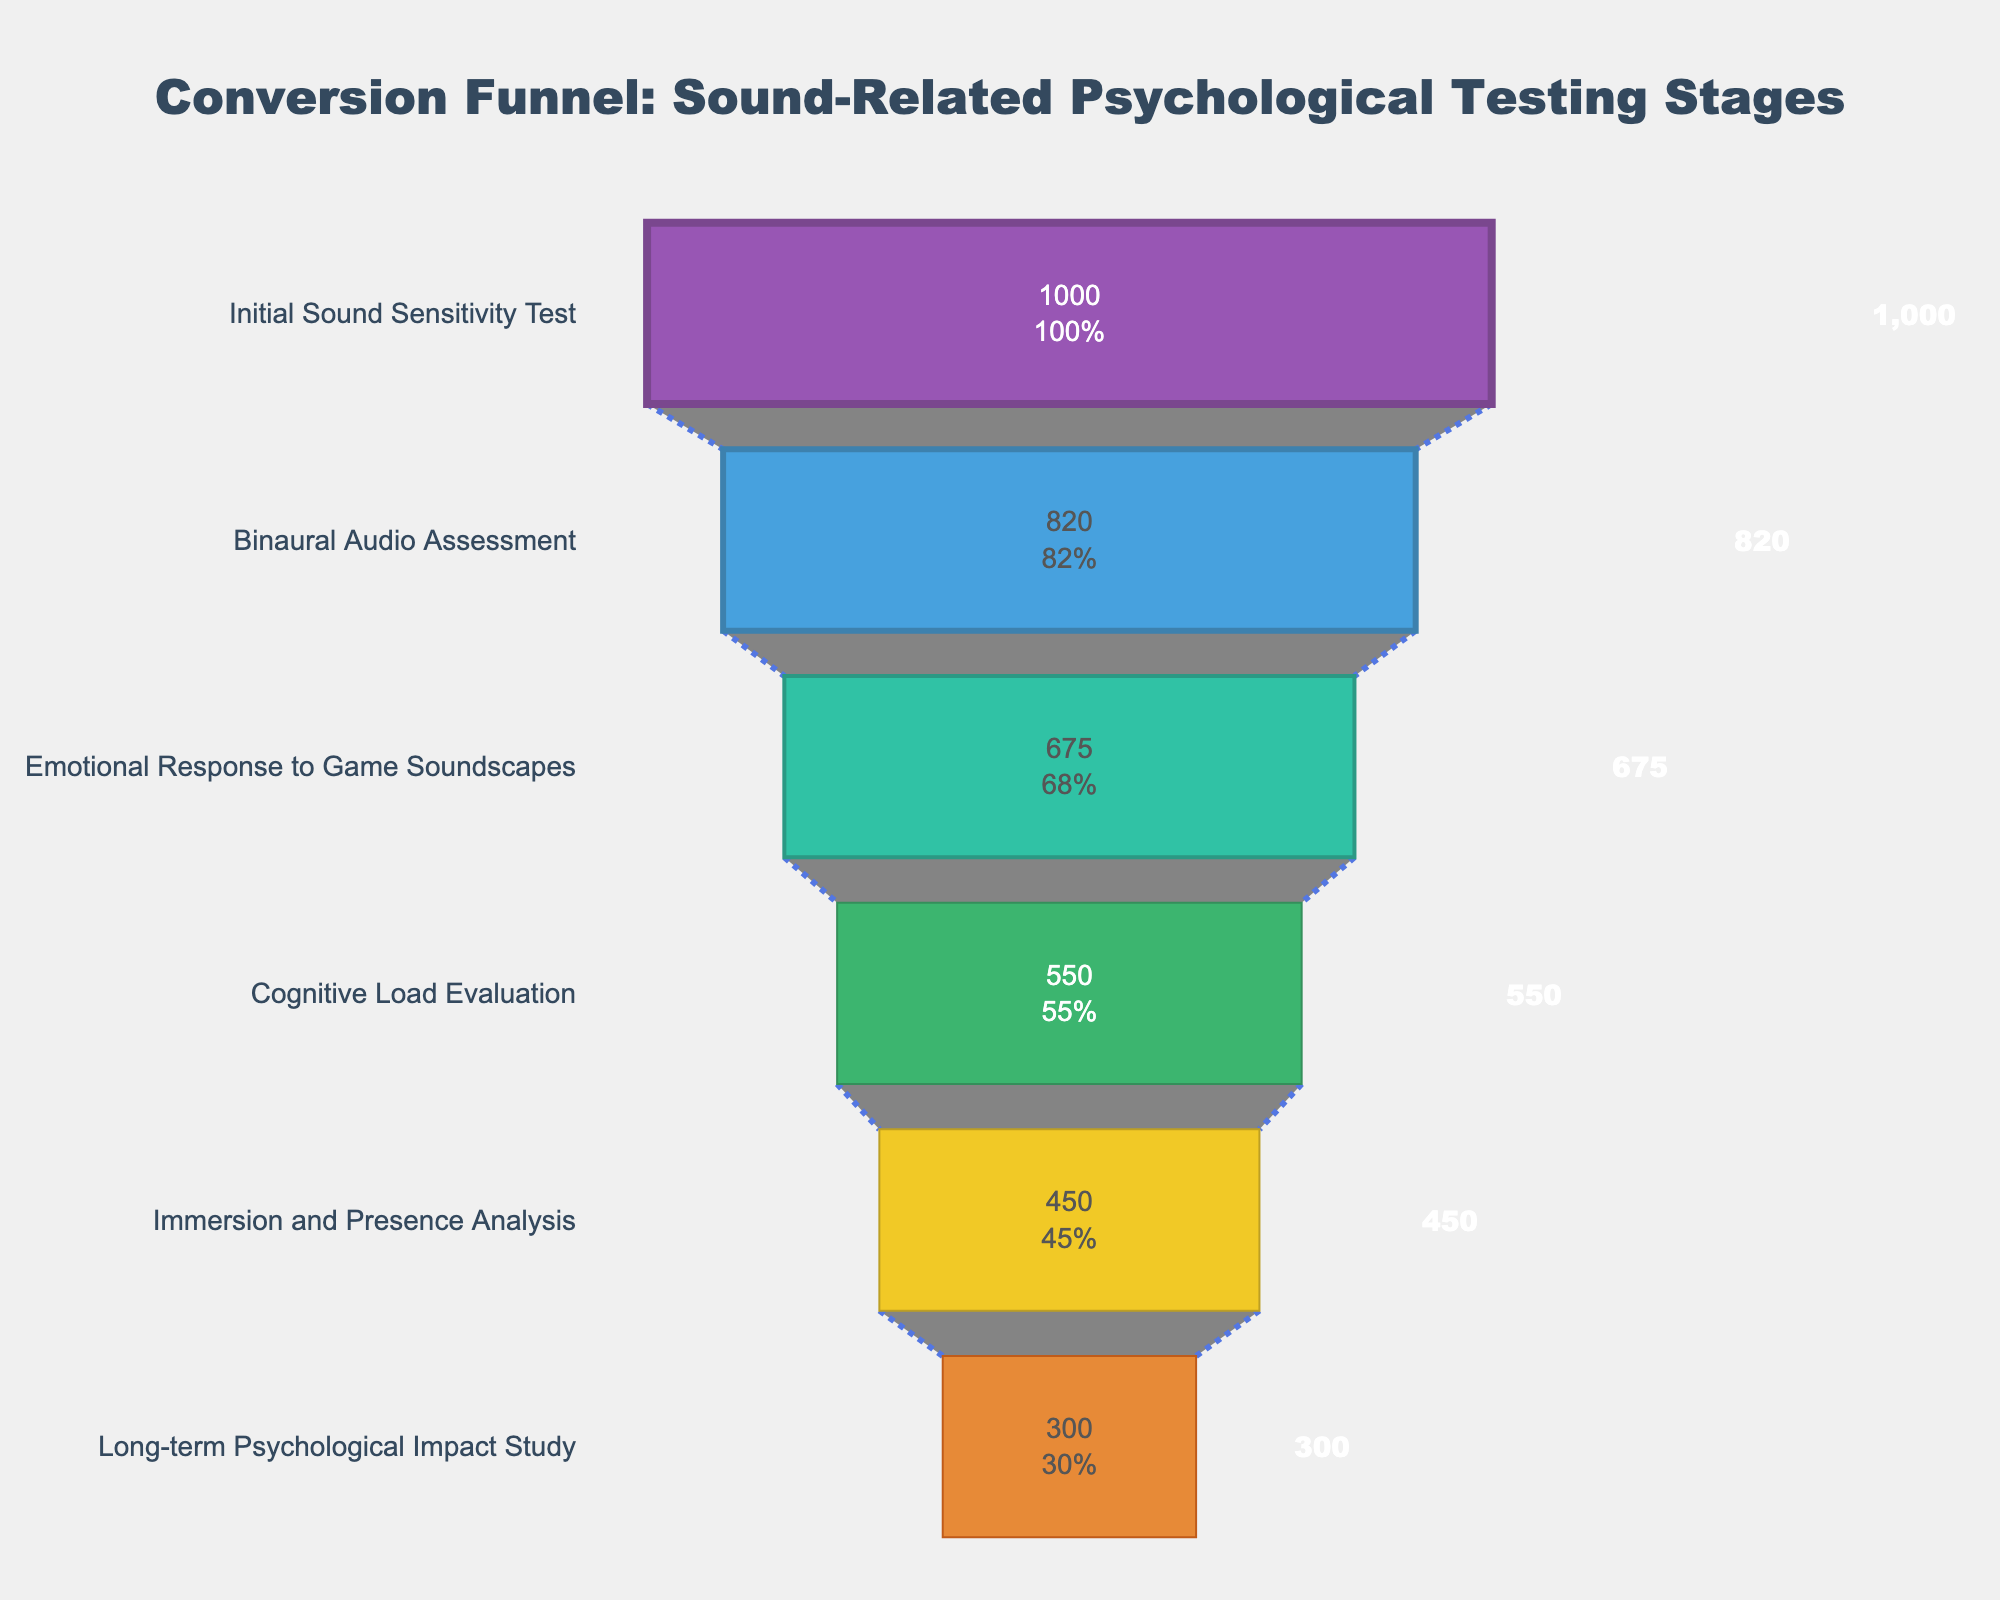What's the stage with the highest number of participants? The stage with the highest number of participants is the first one, as each subsequent stage has fewer participants. According to the funnel chart, the "Initial Sound Sensitivity Test" has the highest number of participants.
Answer: Initial Sound Sensitivity Test How many participants completed the "Cognitive Load Evaluation"? The funnel chart shows that each stage is labeled with the number of participants at that stage. The "Cognitive Load Evaluation" stage has 550 participants.
Answer: 550 What's the percentage drop from the "Initial Sound Sensitivity Test" to the "Binaural Audio Assessment"? The funnel chart provides both numerical and percentage values. Initially, there are 1000 participants, and 820 participants completed the "Binaural Audio Assessment". The percentage drop is ((1000 - 820) / 1000) * 100%.
Answer: 18% How many more participants are there in "Emotional Response to Game Soundscapes" than in "Immersion and Presence Analysis"? According to the funnel chart, "Emotional Response to Game Soundscapes" has 675 participants, and "Immersion and Presence Analysis" has 450 participants. The difference is 675 - 450.
Answer: 225 What's the overall conversion rate from "Initial Sound Sensitivity Test" to "Long-term Psychological Impact Study"? Initially, there are 1000 participants and 300 participants completed the "Long-term Psychological Impact Study." The overall conversion rate is (300 / 1000) * 100%.
Answer: 30% Which stage has the smallest decrease in the number of participants from the previous stage? By examining the difference between stages, the smallest decrease in participants is from "Binaural Audio Assessment" to "Emotional Response to Game Soundscapes" (820 to 675, a difference of 145).
Answer: Emotional Response to Game Soundscapes How many stages have less than 500 participants? The chart has six stages. By checking the number of participants at each stage, "Cognitive Load Evaluation," "Immersion and Presence Analysis," and "Long-term Psychological Impact Study" all have fewer than 500 participants. Thus, three stages have less than 500 participants.
Answer: 3 What's the color of the stage with the second highest number of participants? The funnel chart is color-coded, and the second stage is the "Binaural Audio Assessment" with 820 participants. The color associated with this stage is blue.
Answer: Blue 